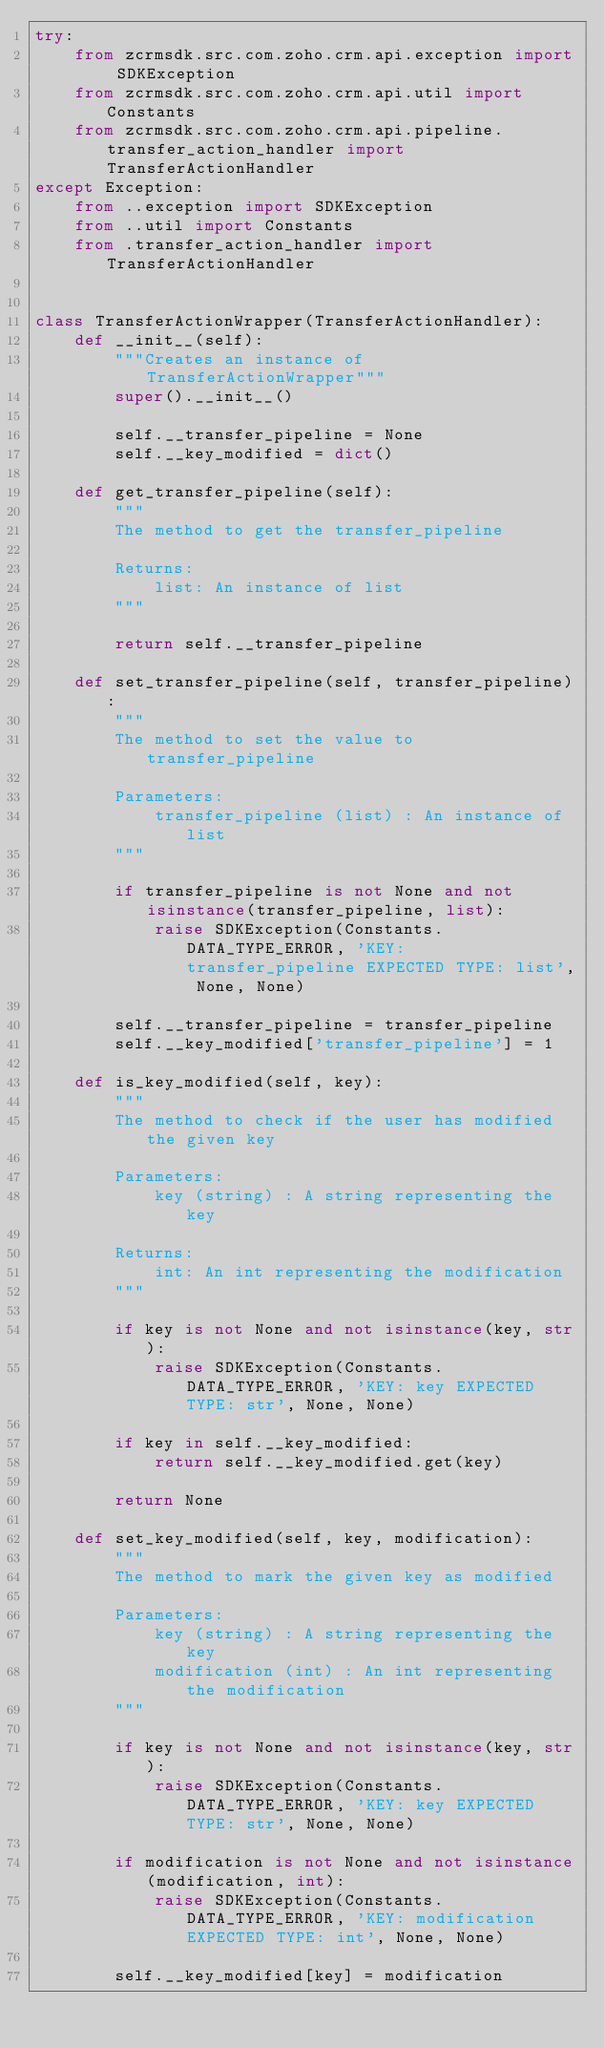Convert code to text. <code><loc_0><loc_0><loc_500><loc_500><_Python_>try:
	from zcrmsdk.src.com.zoho.crm.api.exception import SDKException
	from zcrmsdk.src.com.zoho.crm.api.util import Constants
	from zcrmsdk.src.com.zoho.crm.api.pipeline.transfer_action_handler import TransferActionHandler
except Exception:
	from ..exception import SDKException
	from ..util import Constants
	from .transfer_action_handler import TransferActionHandler


class TransferActionWrapper(TransferActionHandler):
	def __init__(self):
		"""Creates an instance of TransferActionWrapper"""
		super().__init__()

		self.__transfer_pipeline = None
		self.__key_modified = dict()

	def get_transfer_pipeline(self):
		"""
		The method to get the transfer_pipeline

		Returns:
			list: An instance of list
		"""

		return self.__transfer_pipeline

	def set_transfer_pipeline(self, transfer_pipeline):
		"""
		The method to set the value to transfer_pipeline

		Parameters:
			transfer_pipeline (list) : An instance of list
		"""

		if transfer_pipeline is not None and not isinstance(transfer_pipeline, list):
			raise SDKException(Constants.DATA_TYPE_ERROR, 'KEY: transfer_pipeline EXPECTED TYPE: list', None, None)
		
		self.__transfer_pipeline = transfer_pipeline
		self.__key_modified['transfer_pipeline'] = 1

	def is_key_modified(self, key):
		"""
		The method to check if the user has modified the given key

		Parameters:
			key (string) : A string representing the key

		Returns:
			int: An int representing the modification
		"""

		if key is not None and not isinstance(key, str):
			raise SDKException(Constants.DATA_TYPE_ERROR, 'KEY: key EXPECTED TYPE: str', None, None)
		
		if key in self.__key_modified:
			return self.__key_modified.get(key)
		
		return None

	def set_key_modified(self, key, modification):
		"""
		The method to mark the given key as modified

		Parameters:
			key (string) : A string representing the key
			modification (int) : An int representing the modification
		"""

		if key is not None and not isinstance(key, str):
			raise SDKException(Constants.DATA_TYPE_ERROR, 'KEY: key EXPECTED TYPE: str', None, None)
		
		if modification is not None and not isinstance(modification, int):
			raise SDKException(Constants.DATA_TYPE_ERROR, 'KEY: modification EXPECTED TYPE: int', None, None)
		
		self.__key_modified[key] = modification
</code> 